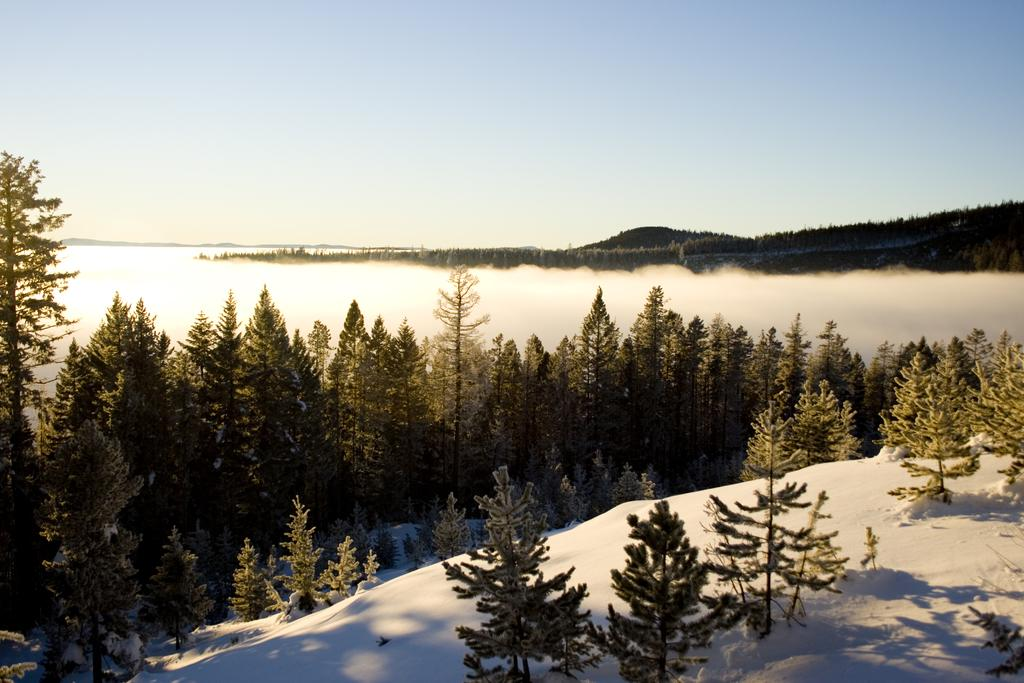What type of vegetation can be seen in the image? There are trees in the image. What natural feature is visible in the background of the image? There is a river in the background of the image. What type of landscape can be seen in the distance in the image? There are mountains in the background of the image. What type of cake is being served at the riverside in the image? There is no cake or indication of a gathering in the image; it primarily features trees, a river, and mountains. 